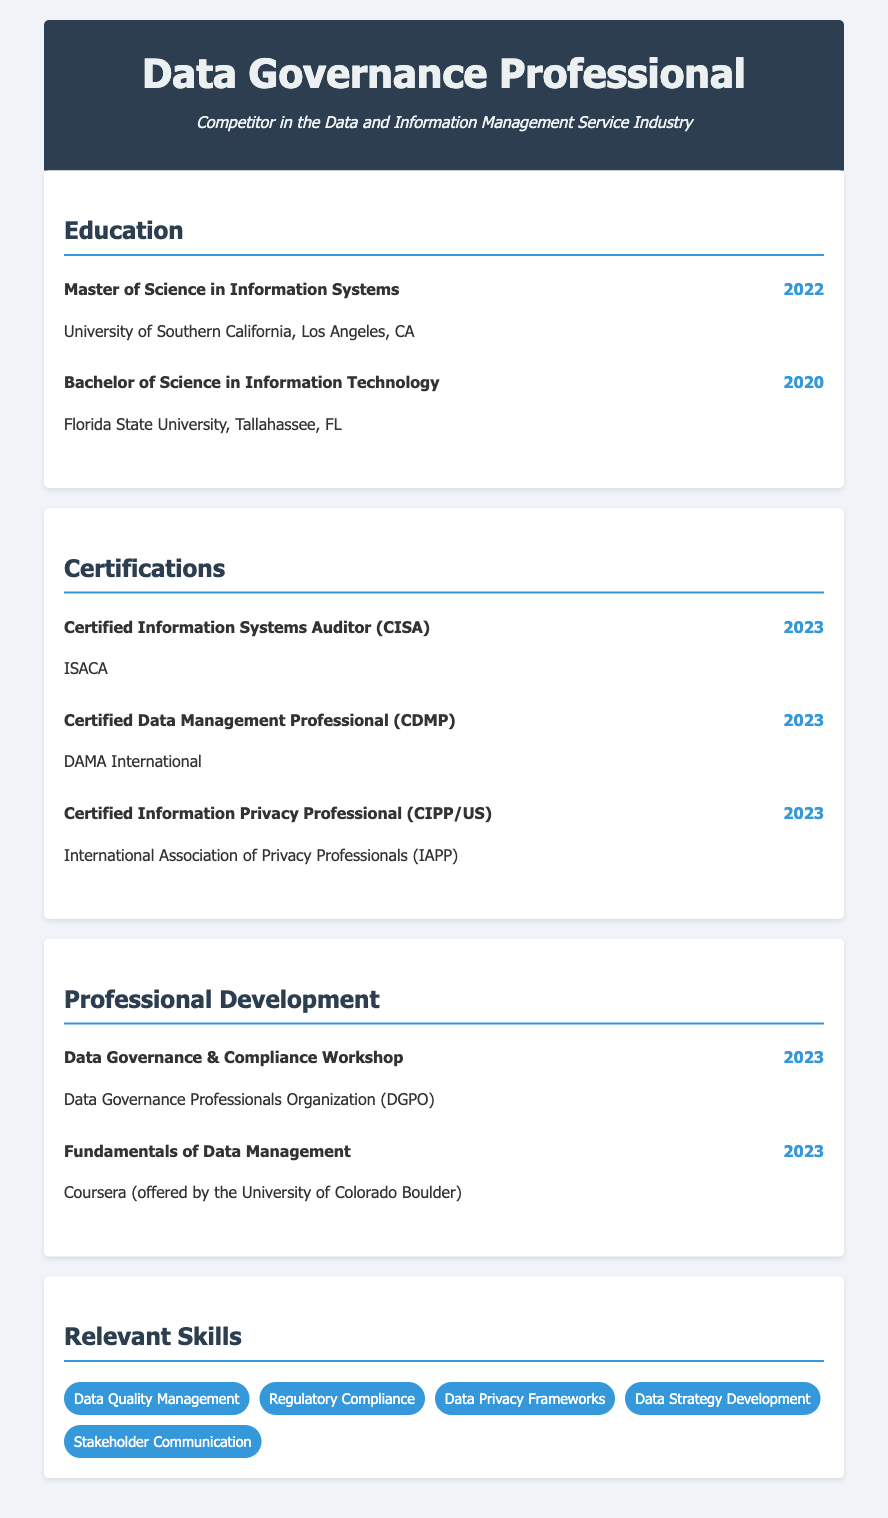what degree was obtained from the University of Southern California? The document states the degree obtained is a Master of Science in Information Systems from the University of Southern California.
Answer: Master of Science in Information Systems what year was the Bachelor of Science in Information Technology awarded? The document specifies that the Bachelor of Science in Information Technology was awarded in the year 2020.
Answer: 2020 how many certifications were achieved in 2023? The document lists three certifications that were achieved in 2023.
Answer: 3 what is the name of the workshop attended for professional development in 2023? The document mentions the Data Governance & Compliance Workshop as a professional development activity attended in 2023.
Answer: Data Governance & Compliance Workshop who awarded the Certified Data Management Professional certification? The certification is awarded by DAMA International according to the document.
Answer: DAMA International which university provided the course for the Fundamentals of Data Management? The document indicates that the course was offered by the University of Colorado Boulder.
Answer: University of Colorado Boulder list one of the relevant skills highlighted in the document. The document includes several relevant skills; one example is Data Quality Management.
Answer: Data Quality Management how many years of education are listed in the document? The document contains two entries under education.
Answer: 2 what does CIPP/US stand for in the certification title? The document refers to it as Certified Information Privacy Professional (CIPP/US).
Answer: Certified Information Privacy Professional 